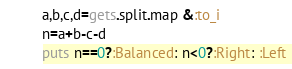<code> <loc_0><loc_0><loc_500><loc_500><_Ruby_>a,b,c,d=gets.split.map &:to_i
n=a+b-c-d
puts n==0?:Balanced: n<0?:Right: :Left
</code> 